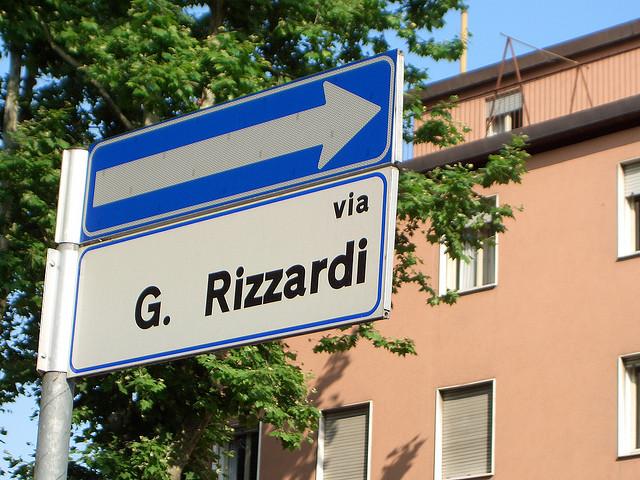What does the arrow represent?
Concise answer only. Go right. What is written on the under the blue sign?
Short answer required. Via g rizzardi. What color is the writing on the sign?
Be succinct. Black. How many trees are there?
Short answer required. 1. 